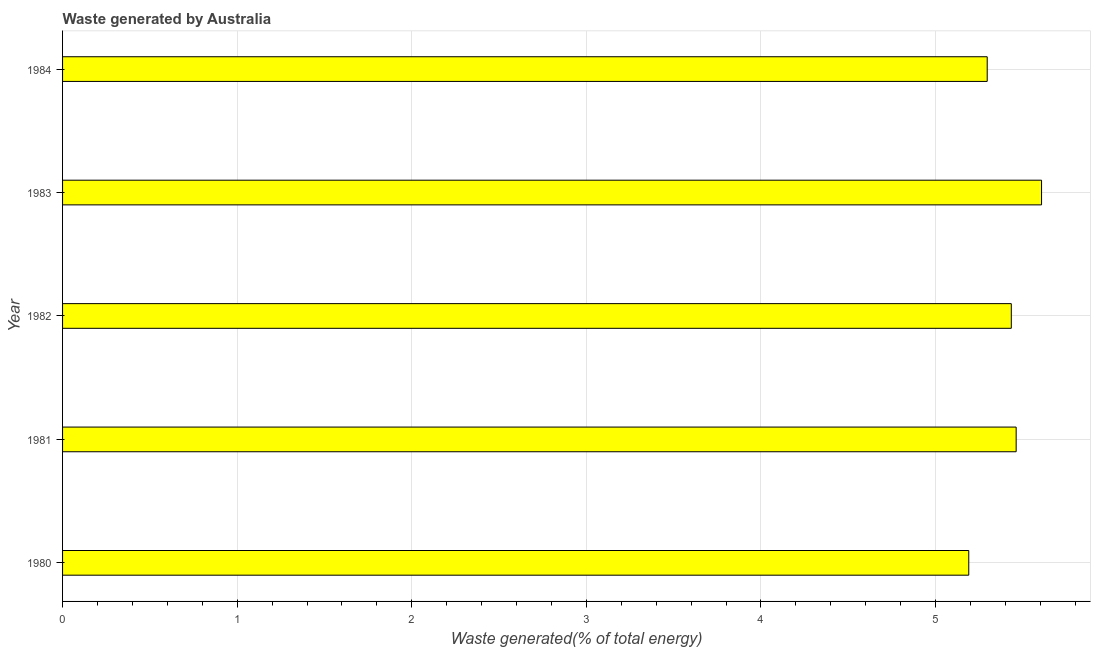Does the graph contain grids?
Your response must be concise. Yes. What is the title of the graph?
Your answer should be very brief. Waste generated by Australia. What is the label or title of the X-axis?
Your answer should be very brief. Waste generated(% of total energy). What is the label or title of the Y-axis?
Make the answer very short. Year. What is the amount of waste generated in 1981?
Your answer should be very brief. 5.46. Across all years, what is the maximum amount of waste generated?
Provide a short and direct response. 5.61. Across all years, what is the minimum amount of waste generated?
Keep it short and to the point. 5.19. In which year was the amount of waste generated maximum?
Offer a terse response. 1983. In which year was the amount of waste generated minimum?
Provide a short and direct response. 1980. What is the sum of the amount of waste generated?
Offer a very short reply. 26.99. What is the difference between the amount of waste generated in 1980 and 1983?
Offer a very short reply. -0.42. What is the average amount of waste generated per year?
Provide a short and direct response. 5.4. What is the median amount of waste generated?
Keep it short and to the point. 5.43. In how many years, is the amount of waste generated greater than 0.2 %?
Your answer should be compact. 5. Is the difference between the amount of waste generated in 1982 and 1983 greater than the difference between any two years?
Offer a very short reply. No. What is the difference between the highest and the second highest amount of waste generated?
Your answer should be very brief. 0.14. What is the difference between the highest and the lowest amount of waste generated?
Your answer should be very brief. 0.42. How many bars are there?
Keep it short and to the point. 5. What is the difference between two consecutive major ticks on the X-axis?
Your answer should be compact. 1. Are the values on the major ticks of X-axis written in scientific E-notation?
Provide a succinct answer. No. What is the Waste generated(% of total energy) of 1980?
Offer a terse response. 5.19. What is the Waste generated(% of total energy) of 1981?
Keep it short and to the point. 5.46. What is the Waste generated(% of total energy) of 1982?
Your answer should be very brief. 5.43. What is the Waste generated(% of total energy) of 1983?
Your answer should be very brief. 5.61. What is the Waste generated(% of total energy) in 1984?
Keep it short and to the point. 5.3. What is the difference between the Waste generated(% of total energy) in 1980 and 1981?
Offer a very short reply. -0.27. What is the difference between the Waste generated(% of total energy) in 1980 and 1982?
Provide a short and direct response. -0.24. What is the difference between the Waste generated(% of total energy) in 1980 and 1983?
Make the answer very short. -0.42. What is the difference between the Waste generated(% of total energy) in 1980 and 1984?
Offer a very short reply. -0.11. What is the difference between the Waste generated(% of total energy) in 1981 and 1982?
Offer a terse response. 0.03. What is the difference between the Waste generated(% of total energy) in 1981 and 1983?
Give a very brief answer. -0.15. What is the difference between the Waste generated(% of total energy) in 1981 and 1984?
Keep it short and to the point. 0.17. What is the difference between the Waste generated(% of total energy) in 1982 and 1983?
Make the answer very short. -0.17. What is the difference between the Waste generated(% of total energy) in 1982 and 1984?
Provide a short and direct response. 0.14. What is the difference between the Waste generated(% of total energy) in 1983 and 1984?
Your answer should be compact. 0.31. What is the ratio of the Waste generated(% of total energy) in 1980 to that in 1981?
Provide a succinct answer. 0.95. What is the ratio of the Waste generated(% of total energy) in 1980 to that in 1982?
Your response must be concise. 0.95. What is the ratio of the Waste generated(% of total energy) in 1980 to that in 1983?
Make the answer very short. 0.93. What is the ratio of the Waste generated(% of total energy) in 1980 to that in 1984?
Provide a short and direct response. 0.98. What is the ratio of the Waste generated(% of total energy) in 1981 to that in 1984?
Your answer should be compact. 1.03. What is the ratio of the Waste generated(% of total energy) in 1983 to that in 1984?
Your answer should be compact. 1.06. 